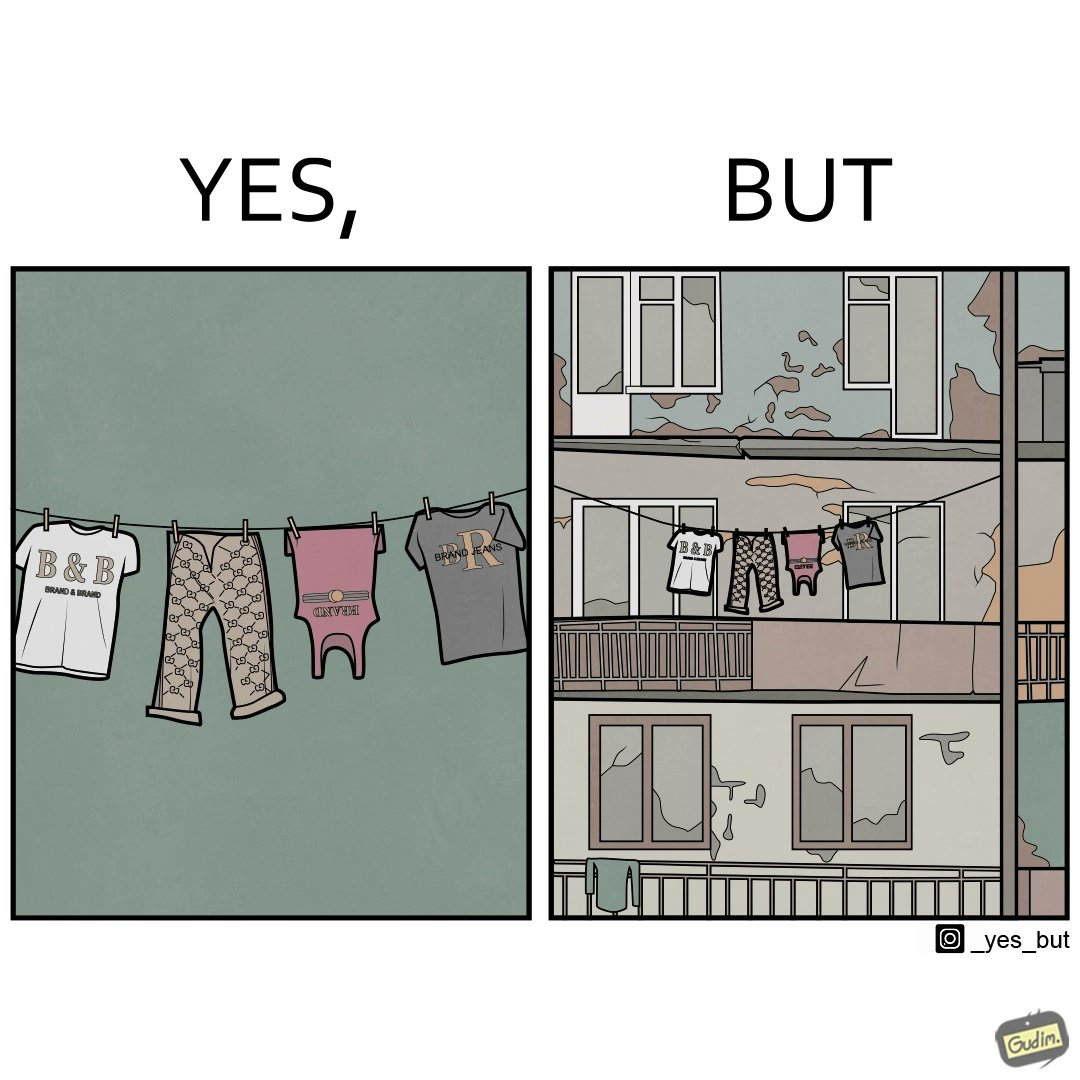What is the satirical meaning behind this image? The image is ironic because although the clothes are of branded companies but they are hanging in very poor building. 